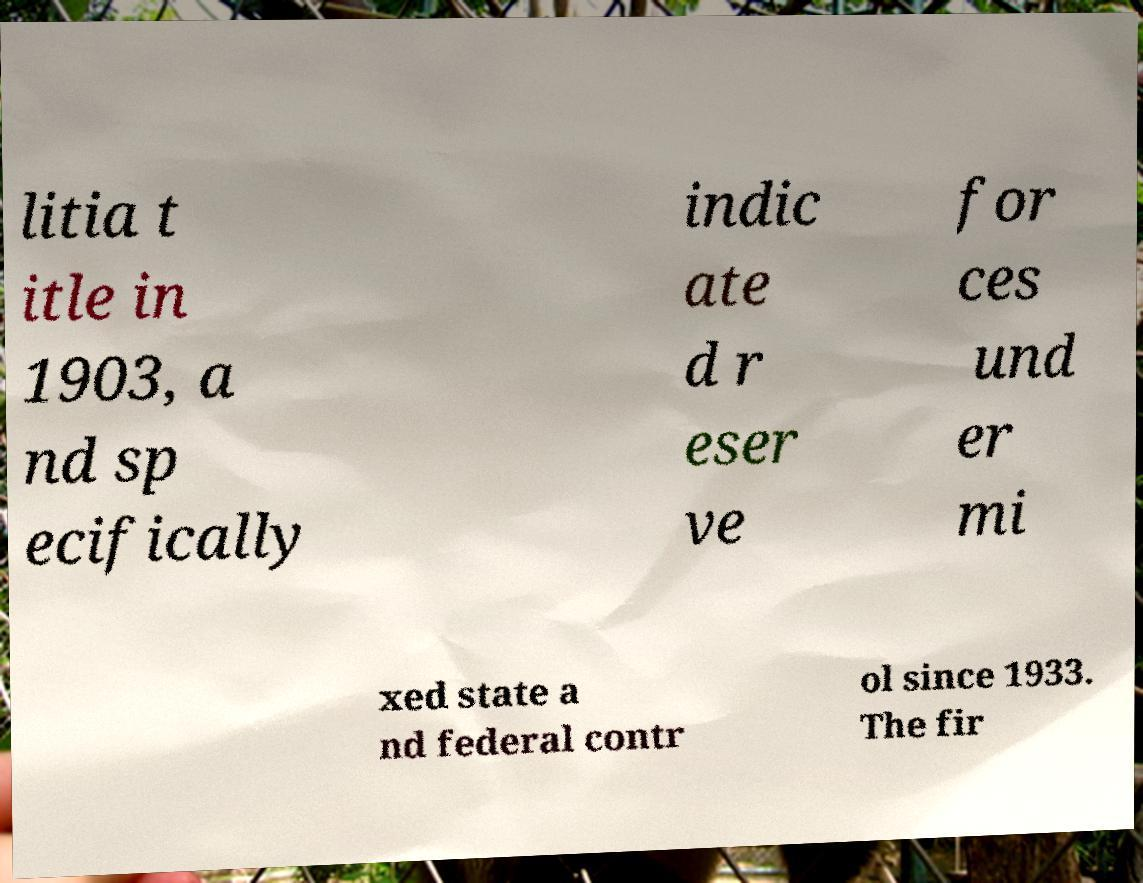Please read and relay the text visible in this image. What does it say? litia t itle in 1903, a nd sp ecifically indic ate d r eser ve for ces und er mi xed state a nd federal contr ol since 1933. The fir 